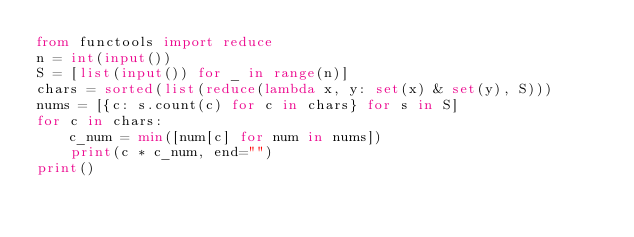<code> <loc_0><loc_0><loc_500><loc_500><_Python_>from functools import reduce
n = int(input())
S = [list(input()) for _ in range(n)]
chars = sorted(list(reduce(lambda x, y: set(x) & set(y), S)))
nums = [{c: s.count(c) for c in chars} for s in S]
for c in chars:
    c_num = min([num[c] for num in nums])
    print(c * c_num, end="")
print()
</code> 